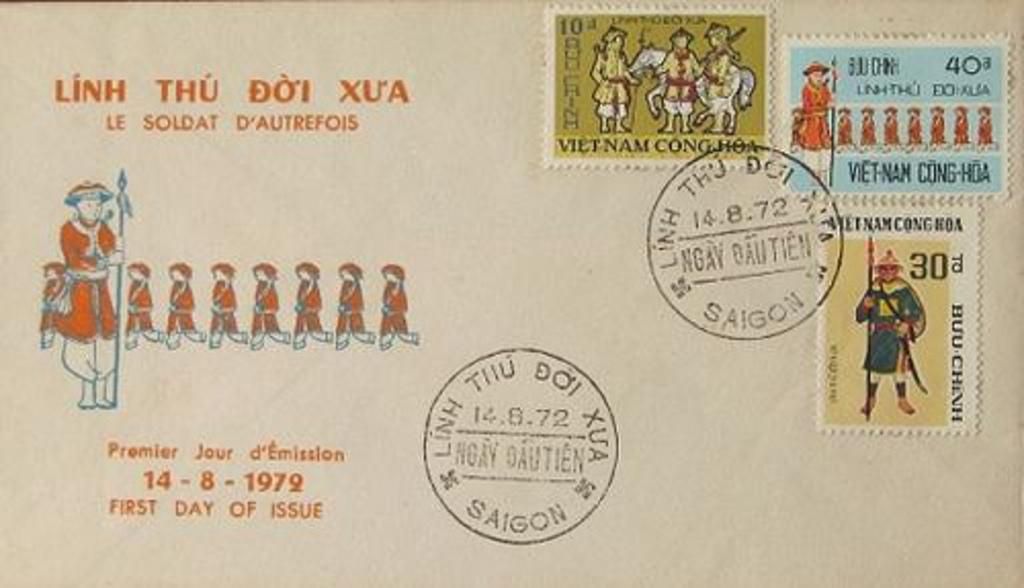Provide a one-sentence caption for the provided image. a postcard with Vietnamese stamps and the words "Linh Thu Doi Xu'a". 